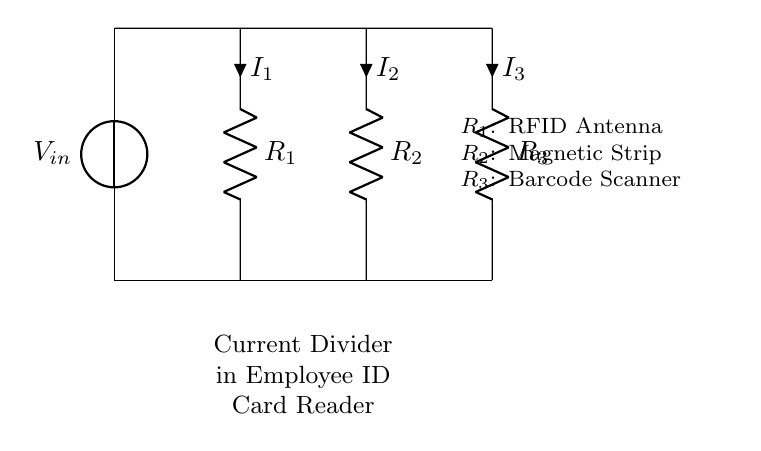What is the input voltage of the circuit? The input voltage, denoted as V_in, is indicated by the voltage source at the top left of the circuit diagram.
Answer: V_in What components are present in the current divider? The diagram shows three resistors labeled R_1, R_2, and R_3, which represent different sections of the employee ID card reader system (RFID Antenna, Magnetic Strip, and Barcode Scanner).
Answer: R_1, R_2, R_3 How many branches are there in the current divider circuit? The circuit shows three resistors in parallel, indicating three distinct branches for the division of current.
Answer: Three What type of circuit is represented in this diagram? The configuration of resistors in parallel, which allows the current to split among components, identifies this design as a current divider circuit.
Answer: Current divider Which resistor corresponds to the RFID Antenna? The diagram labels R_1, which is the first resistor from the left, as corresponding to the RFID Antenna.
Answer: R_1 If the total current entering the circuit is 6 Amps, what current flows through R_2? To find the current through R_2, we first need to apply the current divider rule, which states that the current is inversely proportional to the resistance. Assuming the resistances are known, we can calculate I_2 accordingly. For simplicity, if R_2 has a different resistance compared to others, it may follow that I_2 = (Total Current * (Total Resistance / R_2)).
Answer: Depends on resistances What is the role of the current divider in the employee ID card reader? The current division enables the distribution of the input current to different functional components of the reader, allowing simultaneous operation of all scanning technologies present (RFID, Magnetic Strip, Barcode Scanner).
Answer: Distributes current 